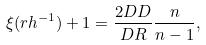Convert formula to latex. <formula><loc_0><loc_0><loc_500><loc_500>\xi ( r h ^ { - 1 } ) + 1 = \frac { 2 D D } { D R } \frac { n } { n - 1 } ,</formula> 